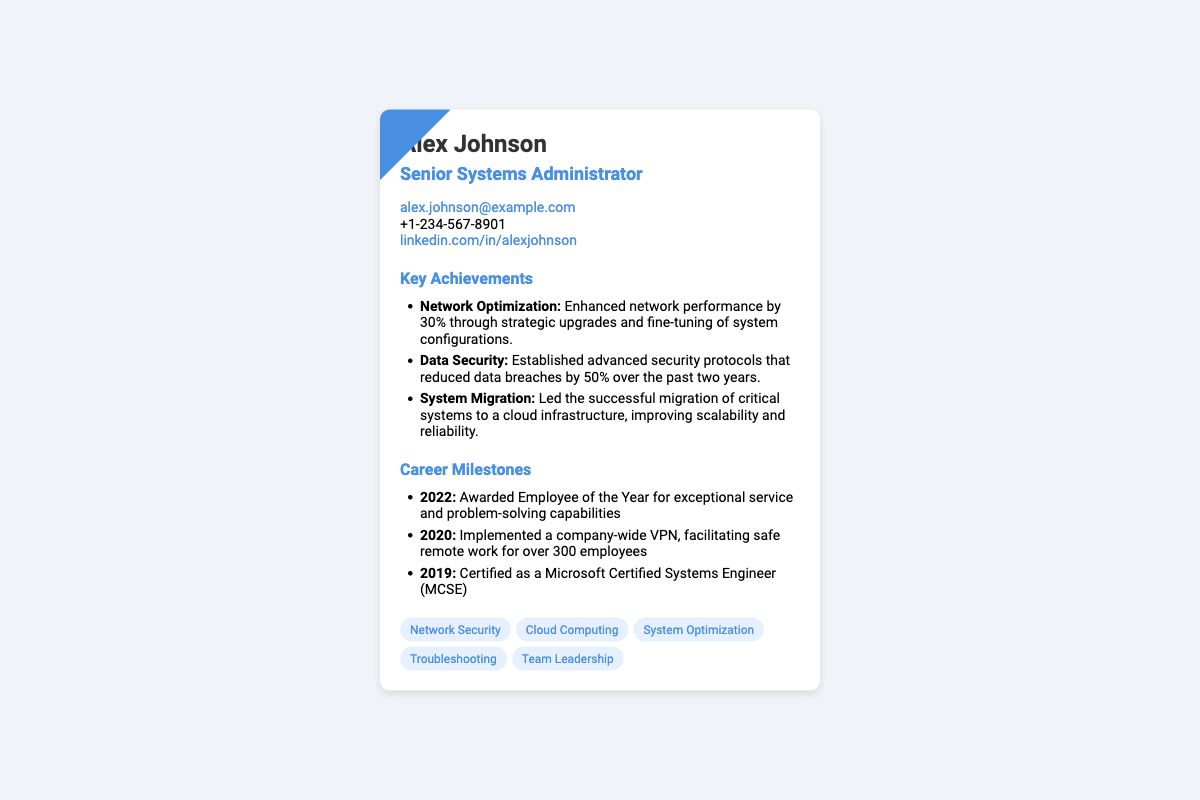What is the name of the systems administrator? The document clearly states the name of the systems administrator as Alex Johnson.
Answer: Alex Johnson What is the title of Alex Johnson? The title listed under his name directly indicates his position within the organization.
Answer: Senior Systems Administrator What email address is provided? The document includes a contact section that specifies Alex's email for communication.
Answer: alex.johnson@example.com In what year was Alex awarded Employee of the Year? The milestones section includes the year Alex received this recognition for his service.
Answer: 2022 What percentage of data breaches was reduced due to security protocols? The achievement section highlights a specific percentage associated with the improvement of data security.
Answer: 50% How many employees benefited from the company-wide VPN implementation? The milestone related to the VPN indicates the number of employees who had safe remote access to the network.
Answer: 300 List one skill mentioned on the card. The card includes a skills section that showcases various abilities of the systems administrator.
Answer: Network Security What type of certification did Alex achieve in 2019? One of the milestones directly mentions the type of certification Alex received in that year.
Answer: Microsoft Certified Systems Engineer What was the improvement percentage in network performance? The achievements section includes a specific percentage indicating the enhancement of network performance across the systems.
Answer: 30% 